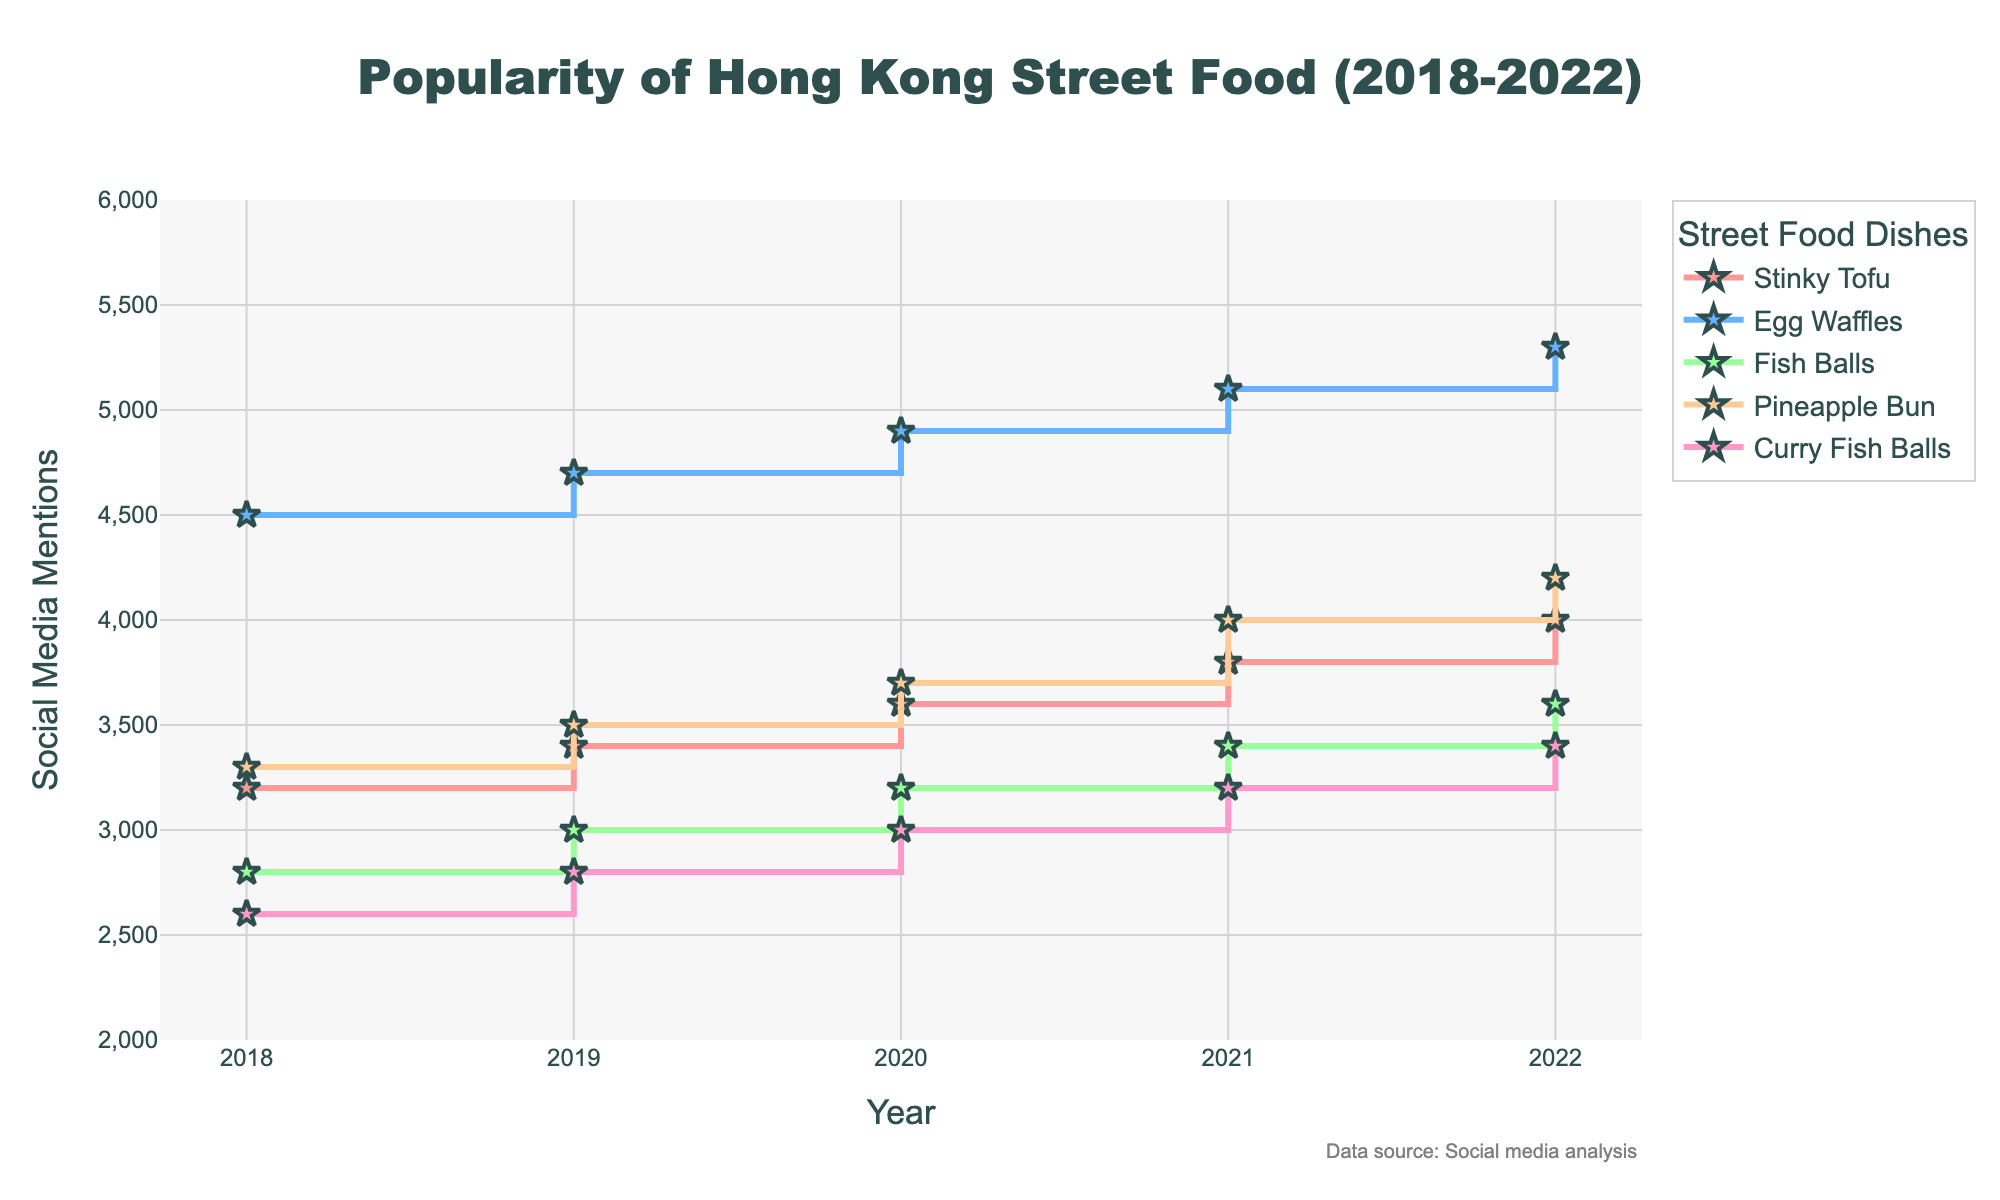what is the title of the plot? The title is typically located at the top of the figure. In this case, it says "Popularity of Hong Kong Street Food (2018-2022)".
Answer: Popularity of Hong Kong Street Food (2018-2022) Which street food dish had the most social media mentions in 2022? Look for the highest value on the y-axis for the year 2022 and note the corresponding dish mentioned in the legend.
Answer: Egg Waffles Did the popularity of Pineapple Bun increase or decrease from 2018 to 2022? Compare the y-values for Pineapple Bun in 2018 and 2022. If the value in 2022 is higher, it increased; if lower, it decreased.
Answer: Increase What is the total increase in social media mentions for Stinky Tofu from 2018 to 2022? Subtract the y-value for Stinky Tofu in 2018 from the y-value for Stinky Tofu in 2022.
Answer: 800 Which dish experienced the smallest increase in mentions from 2018 to 2022? Calculate the increase in mentions for each dish by subtracting the 2018 values from the 2022 values and compare them.
Answer: Curry Fish Balls What is the average number of mentions for Fish Balls across all the years? Sum the mentions for Fish Balls for each year and then divide by the number of years (5).
Answer: 3200 Which year saw the highest increase in mentions for Egg Waffles compared to the previous year? Calculate the yearly increase for Egg Waffles by subtracting the previous year's mentions for each year and find the maximum increase.
Answer: 2021 In what year did Curry Fish Balls reach 3200 mentions? Look at the plot for the year where the y-value for Curry Fish Balls is 3200.
Answer: 2021 Between which two consecutive years did Pineapple Bun see the greatest increase in mentions? Compare the yearly increases for Pineapple Bun by subtracting each year's mentions from the next year's and find the greatest increase.
Answer: 2020 to 2021 By how much did the number of mentions for Fish Balls change from 2019 to 2020? Subtract the mentions of Fish Balls in 2019 from the mentions in 2020.
Answer: 200 